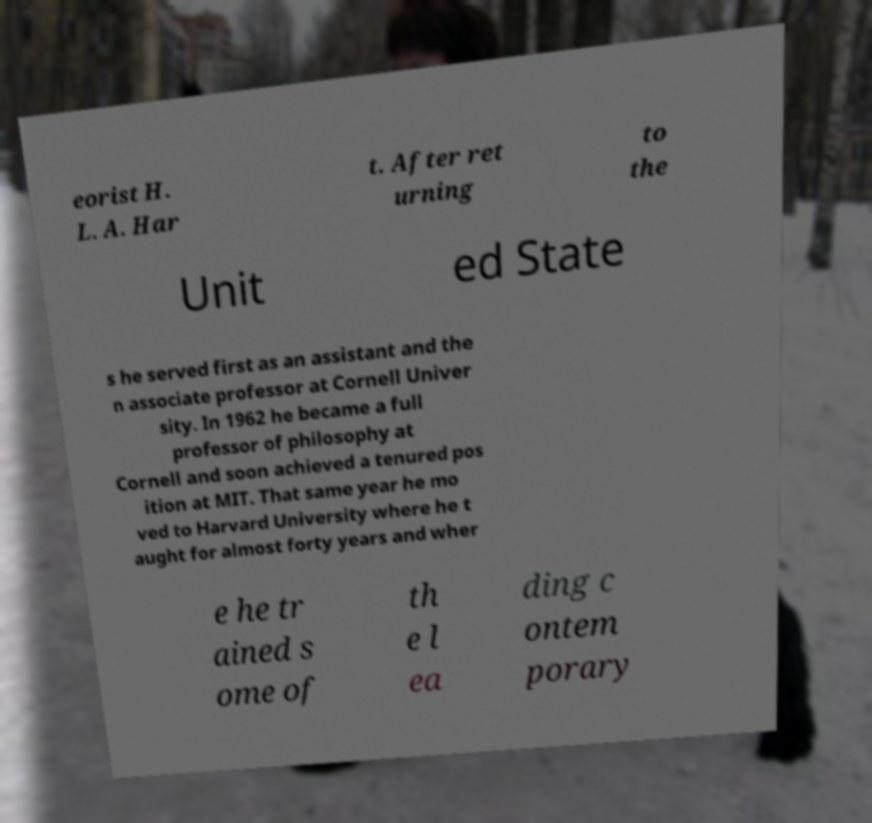Can you read and provide the text displayed in the image?This photo seems to have some interesting text. Can you extract and type it out for me? eorist H. L. A. Har t. After ret urning to the Unit ed State s he served first as an assistant and the n associate professor at Cornell Univer sity. In 1962 he became a full professor of philosophy at Cornell and soon achieved a tenured pos ition at MIT. That same year he mo ved to Harvard University where he t aught for almost forty years and wher e he tr ained s ome of th e l ea ding c ontem porary 